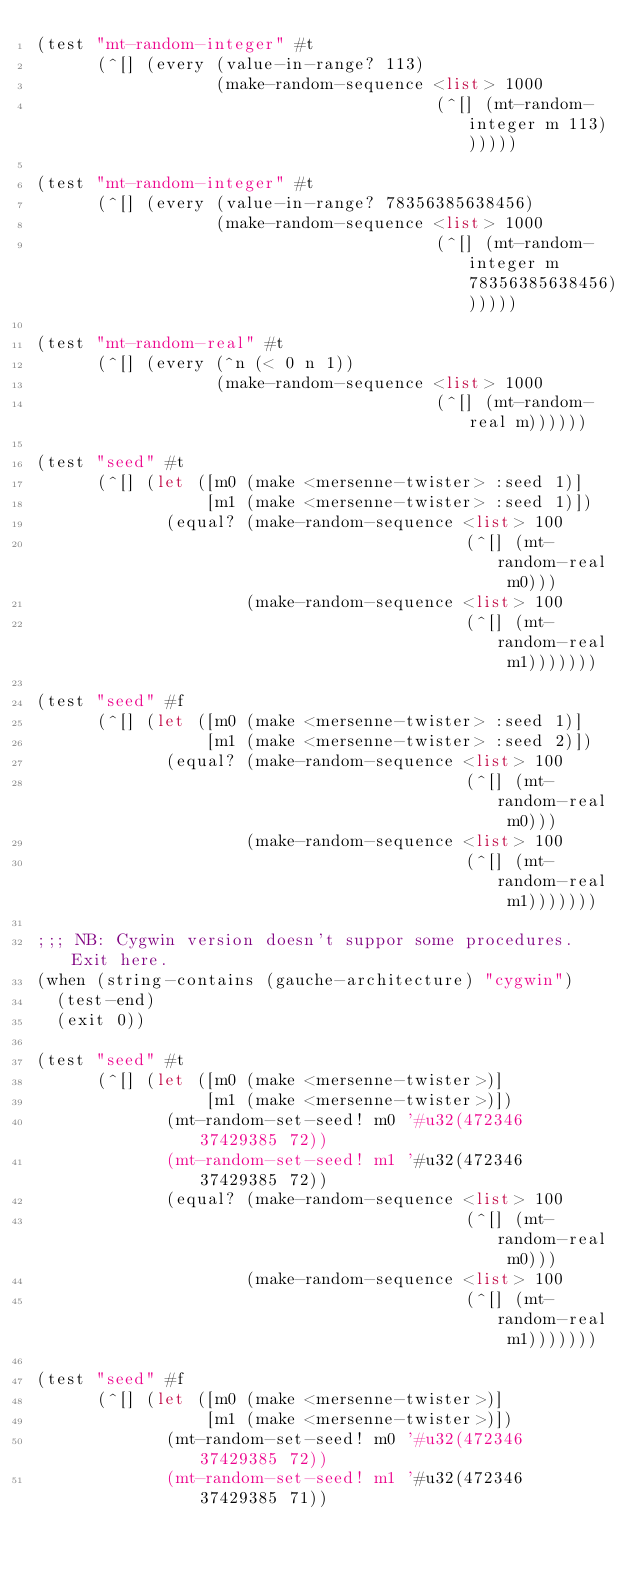<code> <loc_0><loc_0><loc_500><loc_500><_Scheme_>(test "mt-random-integer" #t
      (^[] (every (value-in-range? 113)
                  (make-random-sequence <list> 1000
                                        (^[] (mt-random-integer m 113))))))

(test "mt-random-integer" #t
      (^[] (every (value-in-range? 78356385638456)
                  (make-random-sequence <list> 1000
                                        (^[] (mt-random-integer m 78356385638456))))))

(test "mt-random-real" #t
      (^[] (every (^n (< 0 n 1))
                  (make-random-sequence <list> 1000
                                        (^[] (mt-random-real m))))))

(test "seed" #t
      (^[] (let ([m0 (make <mersenne-twister> :seed 1)]
                 [m1 (make <mersenne-twister> :seed 1)])
             (equal? (make-random-sequence <list> 100
                                           (^[] (mt-random-real m0)))
                     (make-random-sequence <list> 100
                                           (^[] (mt-random-real m1)))))))

(test "seed" #f
      (^[] (let ([m0 (make <mersenne-twister> :seed 1)]
                 [m1 (make <mersenne-twister> :seed 2)])
             (equal? (make-random-sequence <list> 100
                                           (^[] (mt-random-real m0)))
                     (make-random-sequence <list> 100
                                           (^[] (mt-random-real m1)))))))

;;; NB: Cygwin version doesn't suppor some procedures.  Exit here.
(when (string-contains (gauche-architecture) "cygwin")
  (test-end)
  (exit 0))

(test "seed" #t
      (^[] (let ([m0 (make <mersenne-twister>)]
                 [m1 (make <mersenne-twister>)])
             (mt-random-set-seed! m0 '#u32(472346 37429385 72))
             (mt-random-set-seed! m1 '#u32(472346 37429385 72))
             (equal? (make-random-sequence <list> 100
                                           (^[] (mt-random-real m0)))
                     (make-random-sequence <list> 100
                                           (^[] (mt-random-real m1)))))))

(test "seed" #f
      (^[] (let ([m0 (make <mersenne-twister>)]
                 [m1 (make <mersenne-twister>)])
             (mt-random-set-seed! m0 '#u32(472346 37429385 72))
             (mt-random-set-seed! m1 '#u32(472346 37429385 71))</code> 